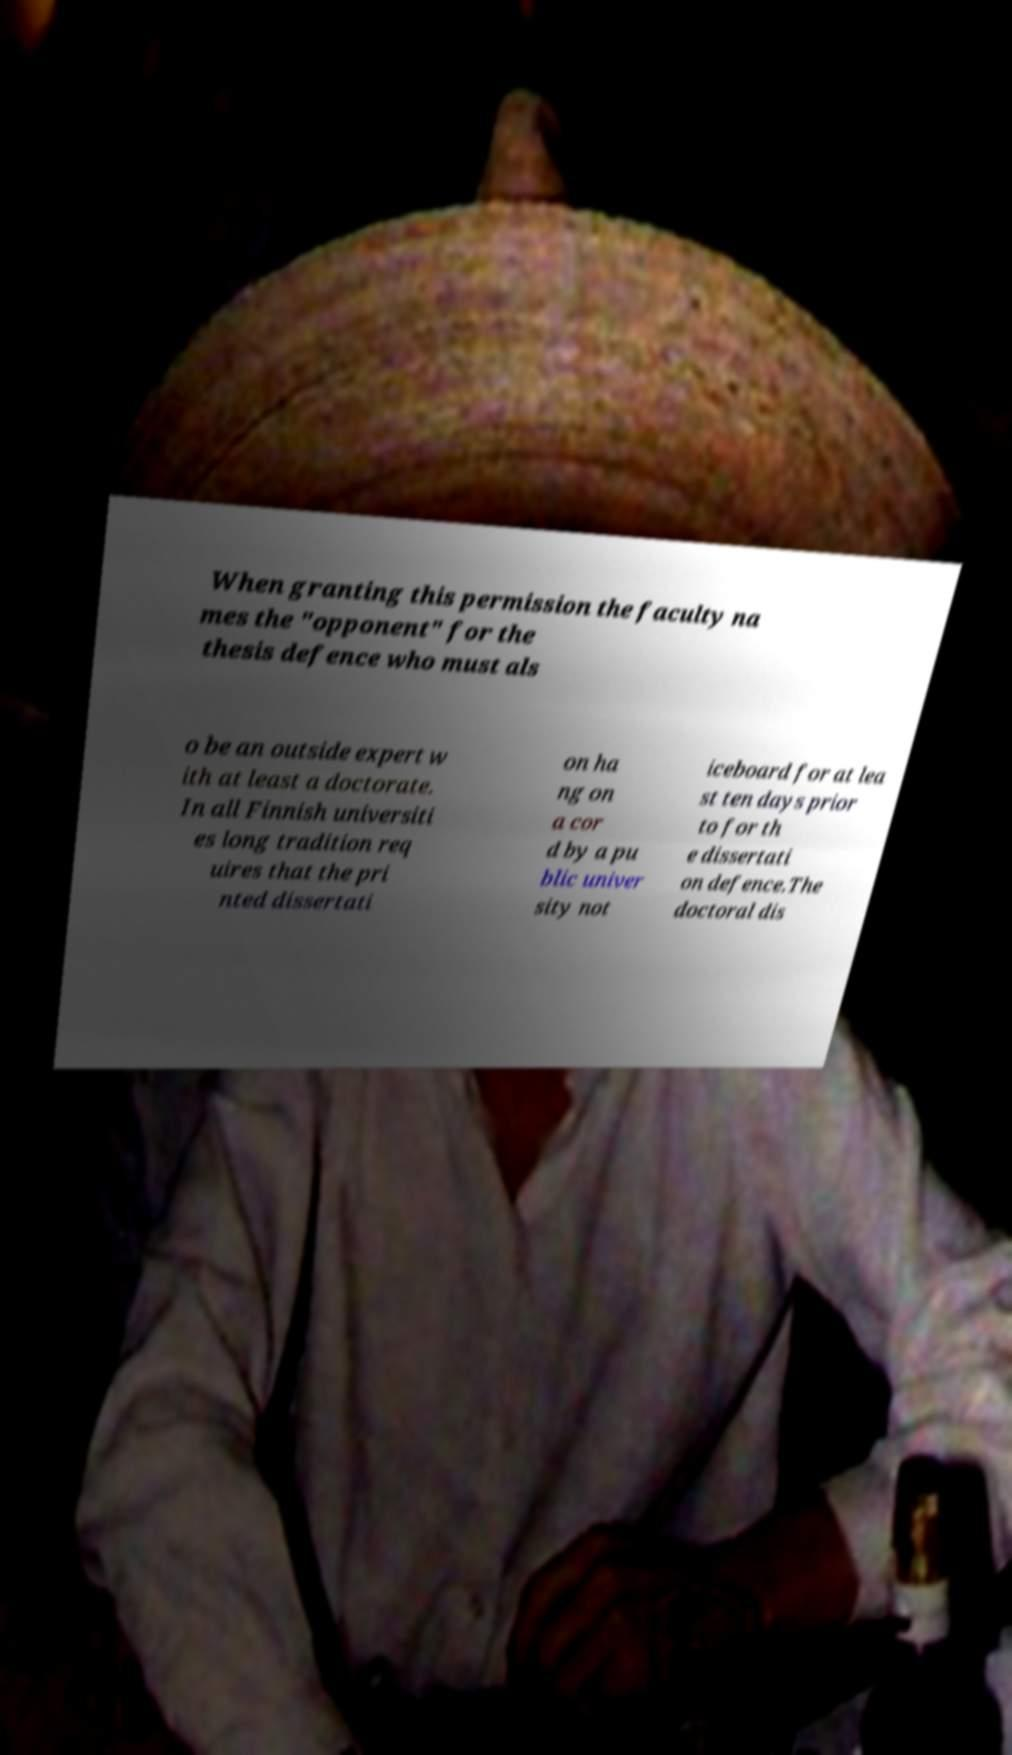Please identify and transcribe the text found in this image. When granting this permission the faculty na mes the "opponent" for the thesis defence who must als o be an outside expert w ith at least a doctorate. In all Finnish universiti es long tradition req uires that the pri nted dissertati on ha ng on a cor d by a pu blic univer sity not iceboard for at lea st ten days prior to for th e dissertati on defence.The doctoral dis 